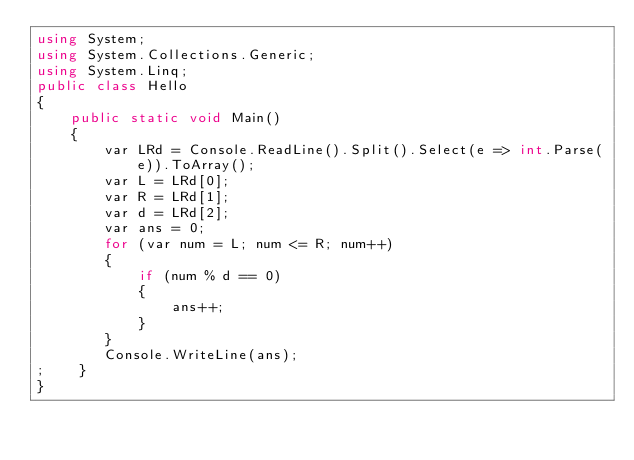<code> <loc_0><loc_0><loc_500><loc_500><_C#_>using System;
using System.Collections.Generic;
using System.Linq;
public class Hello
{
    public static void Main()
    {
        var LRd = Console.ReadLine().Split().Select(e => int.Parse(e)).ToArray();
        var L = LRd[0];
        var R = LRd[1];
        var d = LRd[2];
        var ans = 0;
        for (var num = L; num <= R; num++)
        {
            if (num % d == 0)
            {
                ans++;
            }
        }
        Console.WriteLine(ans);
;    }
}
</code> 